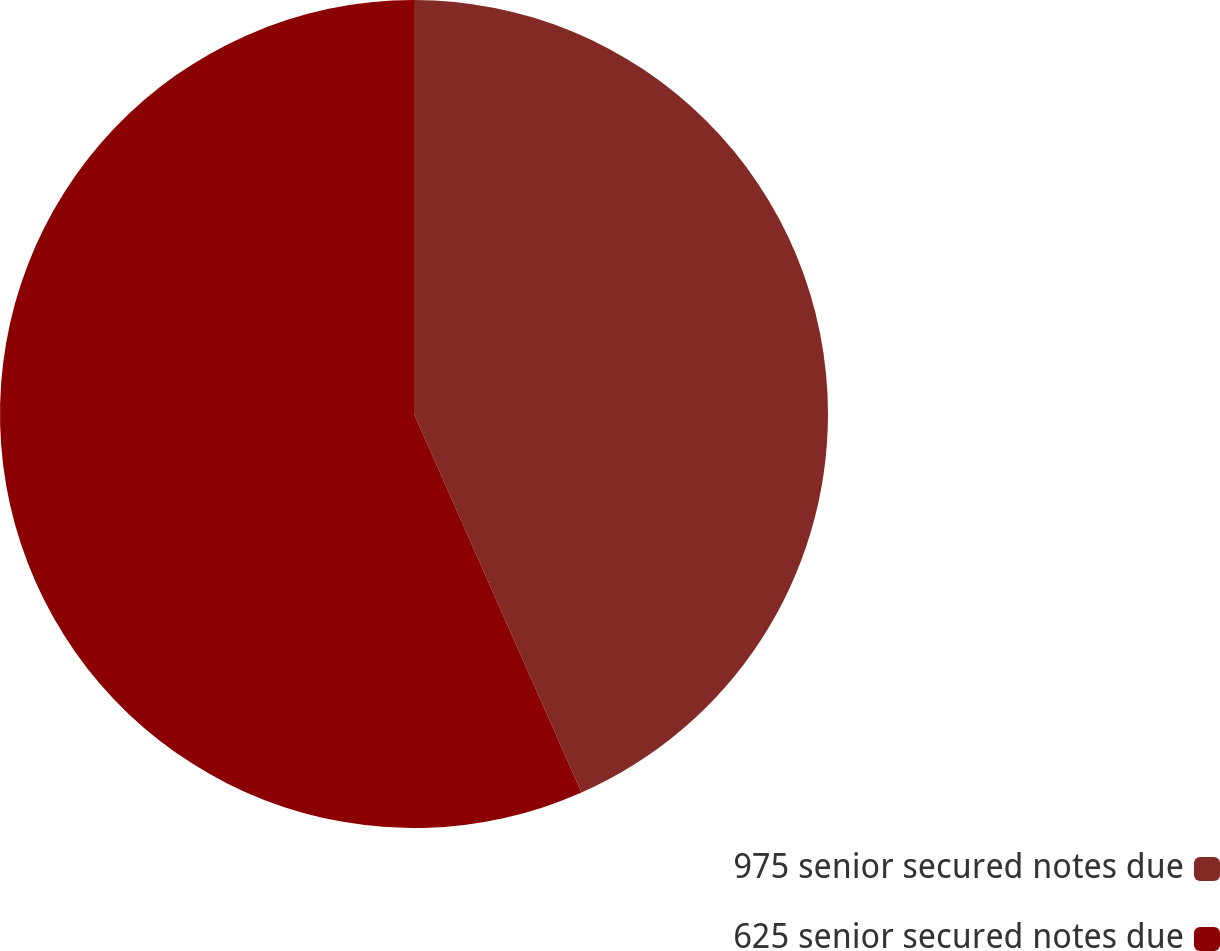Convert chart to OTSL. <chart><loc_0><loc_0><loc_500><loc_500><pie_chart><fcel>975 senior secured notes due<fcel>625 senior secured notes due<nl><fcel>43.37%<fcel>56.63%<nl></chart> 